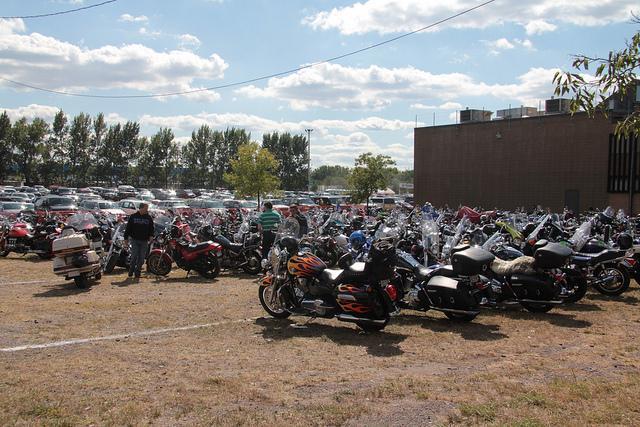How many motorcycles can be seen?
Give a very brief answer. 8. How many rolls of toilet paper?
Give a very brief answer. 0. 